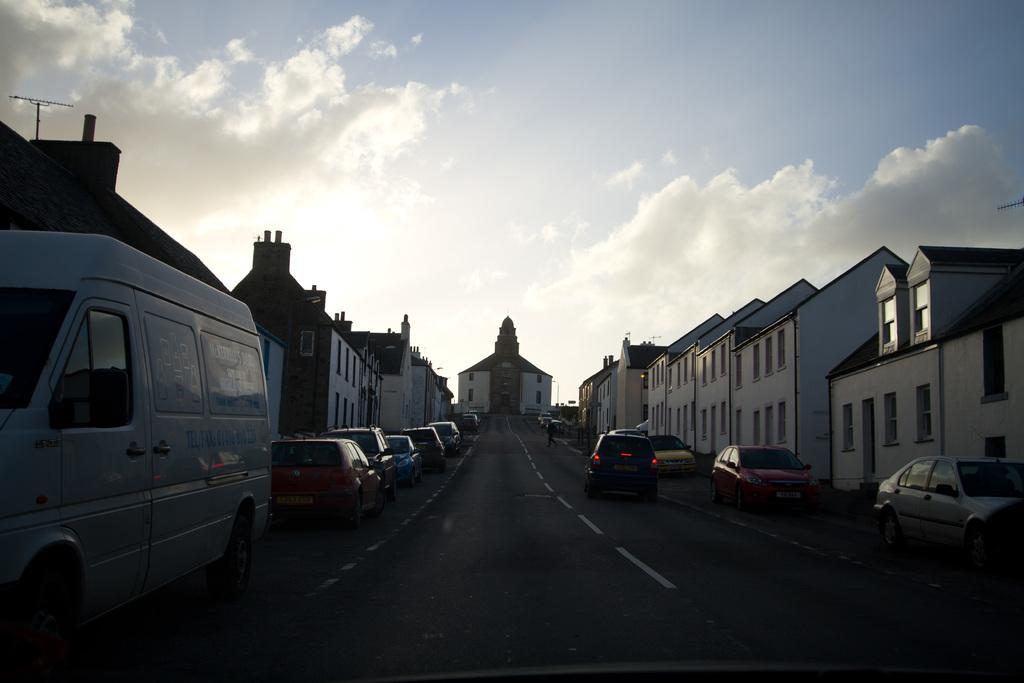What is at the bottom of the image? There is a road at the bottom of the image. What is happening on the road? There are many cars on the road. What can be seen on both sides of the road? There are buildings on both sides of the road. What is visible at the top of the image? The sky is visible at the top of the image. What can be observed in the sky? Clouds are present in the sky. Can you see a guitar being played on the side of the road? There is no guitar or anyone playing it in the image. How many feet are visible on the road? There are no feet visible in the image; it only shows cars, buildings, and the sky. 